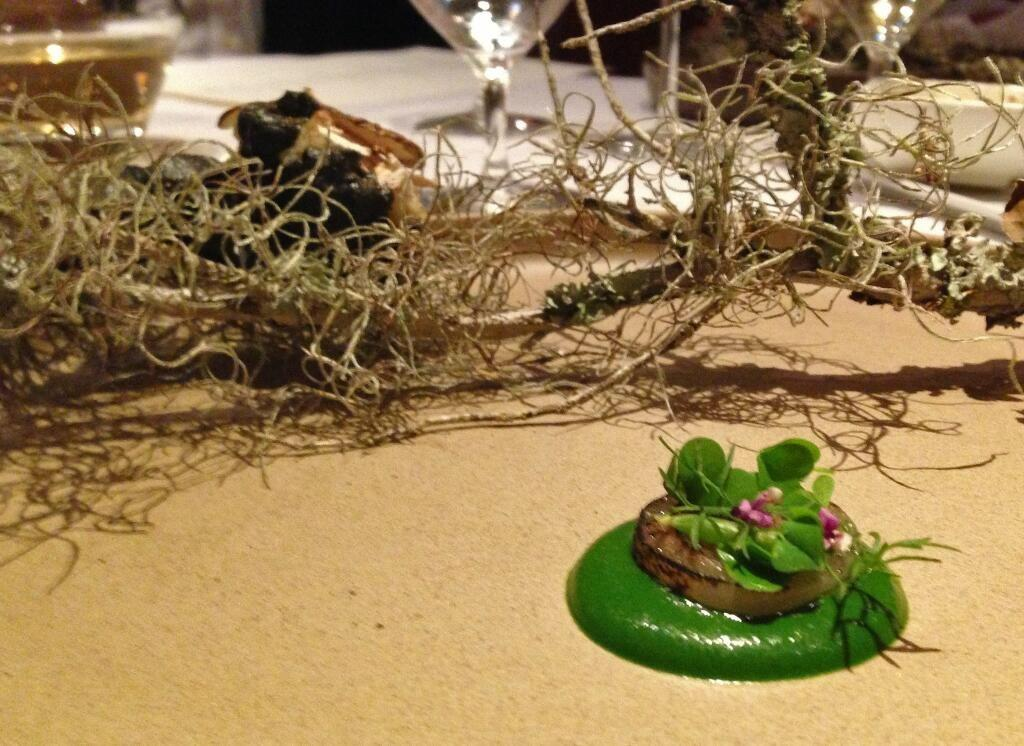What is on the plate that is visible in the image? There is food on a plate in the image. What else can be seen in the image besides the plate of food? There are wine glasses on a table in the background of the image. How many brothers are present in the image? There is no information about brothers in the image, as it only shows food on a plate and wine glasses on a table. 